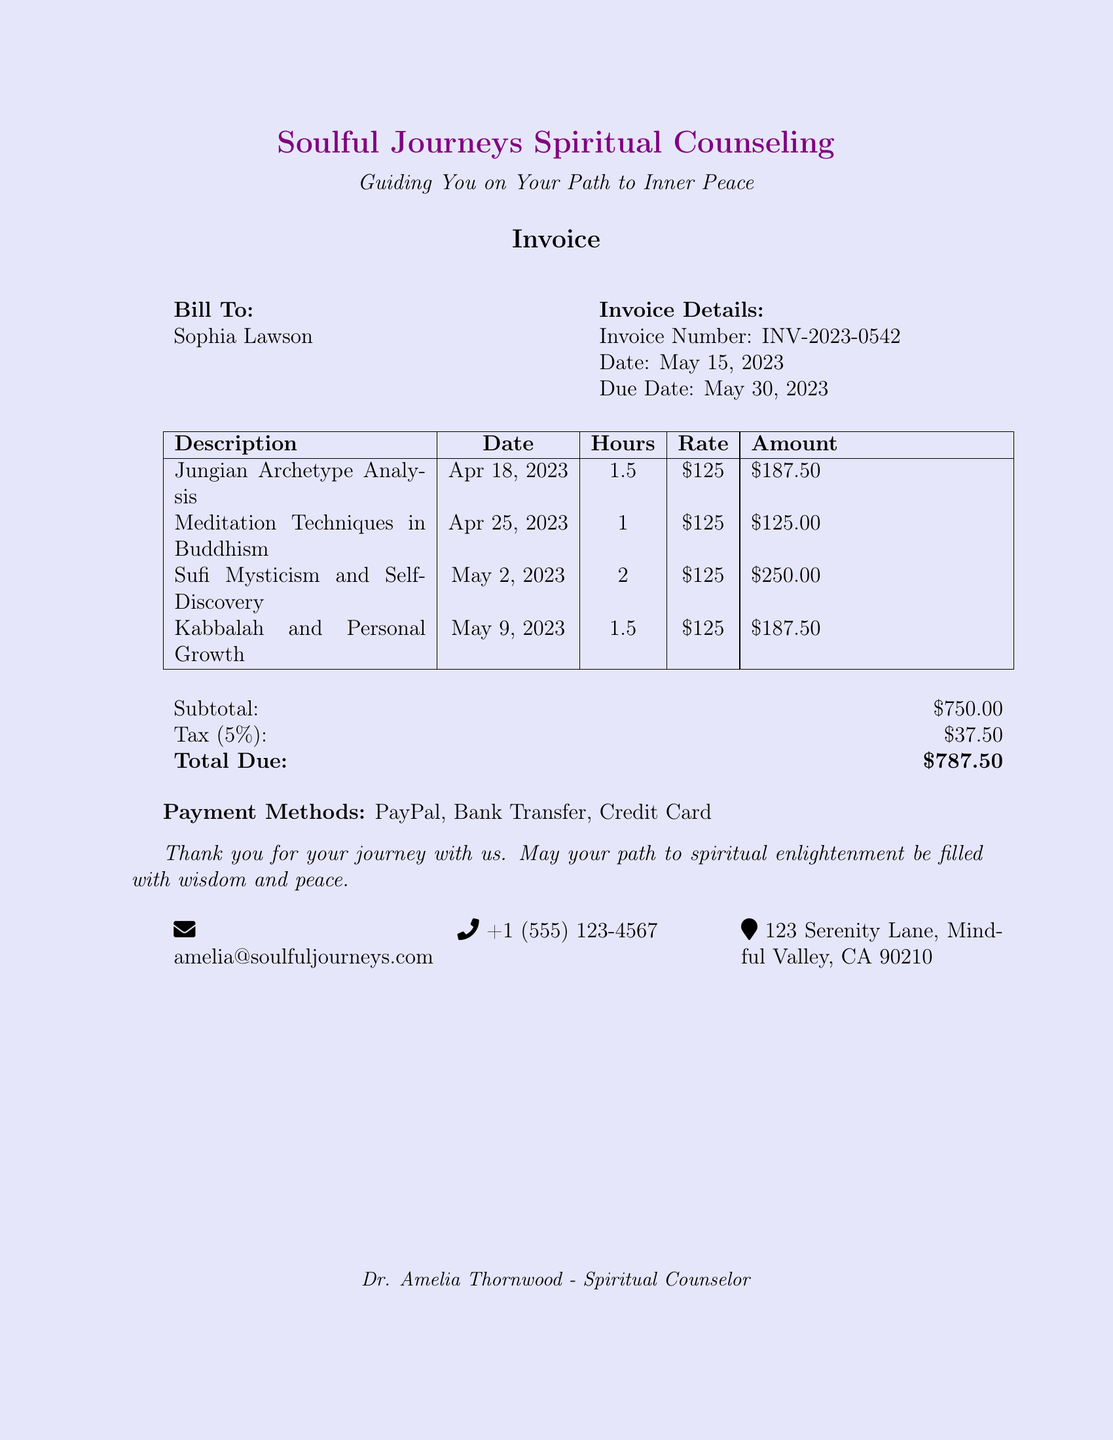What is the name of the counseling service? The name of the counseling service can be found in the header of the document.
Answer: Soulful Journeys Spiritual Counseling What is the invoice number? The invoice number is stated in the invoice details section.
Answer: INV-2023-0542 What is the date of the invoice? The invoice date is specified in the invoice details section.
Answer: May 15, 2023 How much is charged per hour for the sessions? The hourly rate is provided in the table for each session description.
Answer: $125 What is the total amount due? The total amount due can be found at the bottom of the invoice summary.
Answer: $787.50 Which session lasted the longest? The longest session duration is listed in the descriptions of the sessions.
Answer: Sufi Mysticism and Self-Discovery What percentage is the tax applied? The tax percentage is shown in the invoice subtotal section.
Answer: 5% When is the due date for payment? The due date is specified in the invoice details section.
Answer: May 30, 2023 What payment methods are accepted? The accepted payment methods are stated explicitly at the bottom of the document.
Answer: PayPal, Bank Transfer, Credit Card 